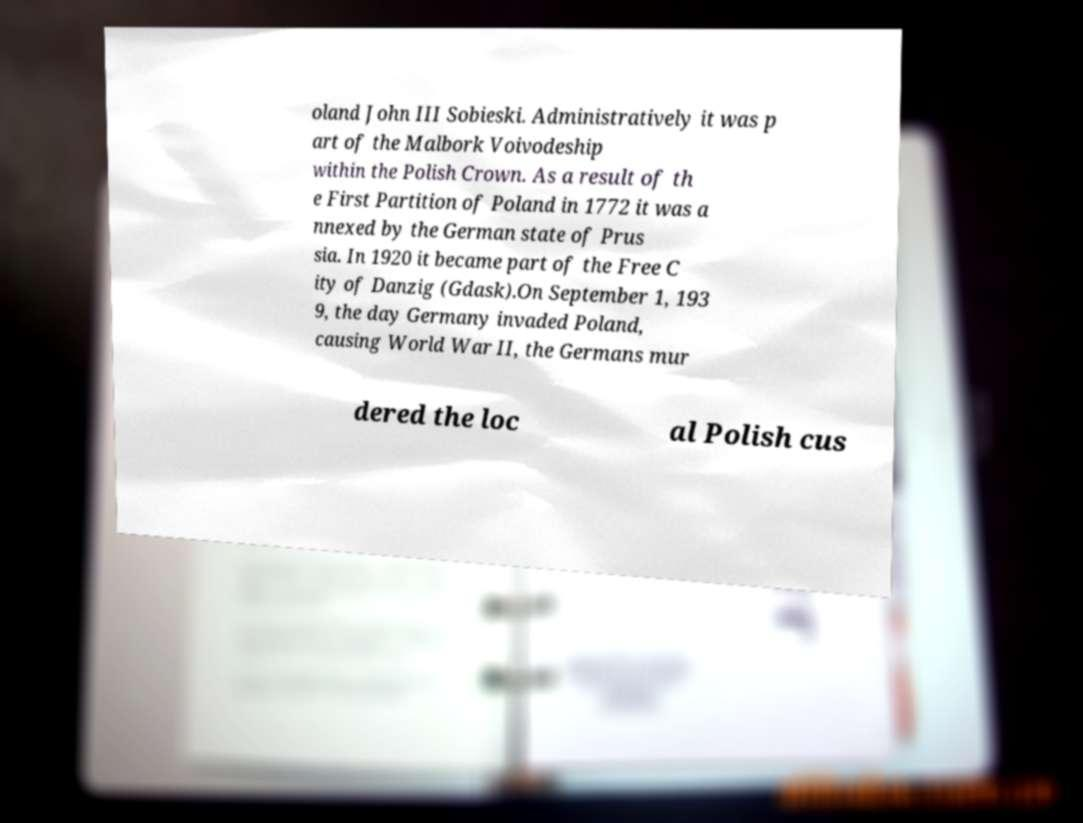What messages or text are displayed in this image? I need them in a readable, typed format. oland John III Sobieski. Administratively it was p art of the Malbork Voivodeship within the Polish Crown. As a result of th e First Partition of Poland in 1772 it was a nnexed by the German state of Prus sia. In 1920 it became part of the Free C ity of Danzig (Gdask).On September 1, 193 9, the day Germany invaded Poland, causing World War II, the Germans mur dered the loc al Polish cus 